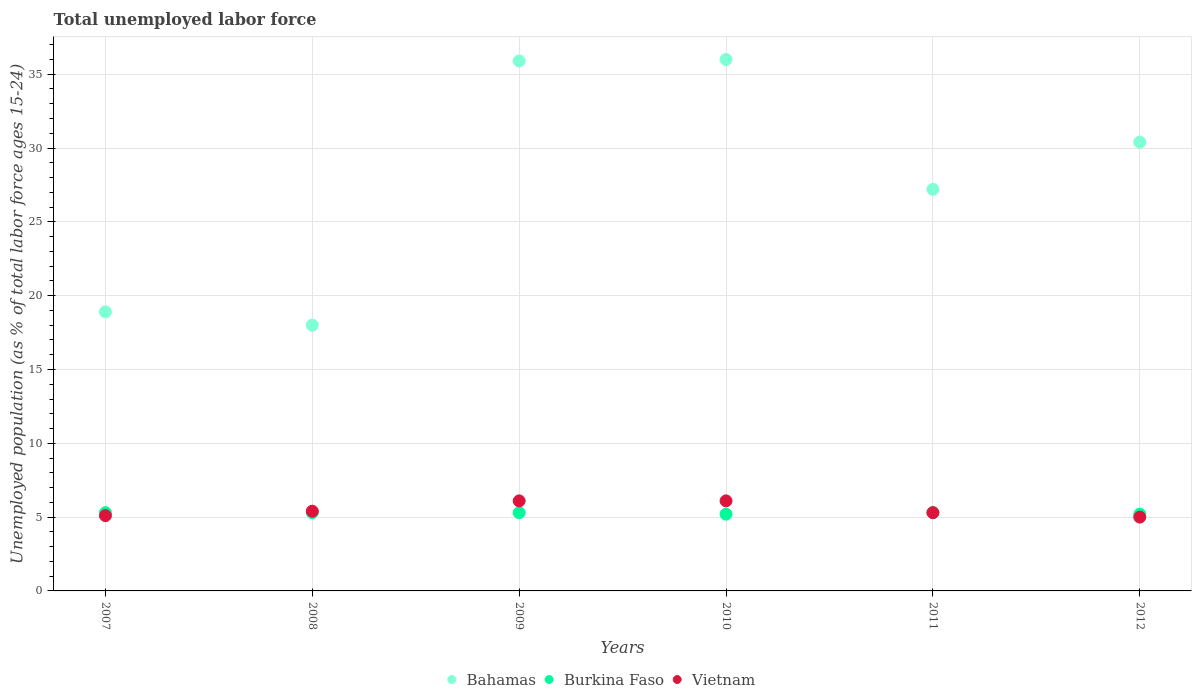Is the number of dotlines equal to the number of legend labels?
Give a very brief answer. Yes. What is the percentage of unemployed population in in Bahamas in 2007?
Offer a very short reply. 18.9. Across all years, what is the maximum percentage of unemployed population in in Vietnam?
Provide a short and direct response. 6.1. Across all years, what is the minimum percentage of unemployed population in in Bahamas?
Give a very brief answer. 18. What is the total percentage of unemployed population in in Bahamas in the graph?
Make the answer very short. 166.4. What is the difference between the percentage of unemployed population in in Bahamas in 2007 and that in 2011?
Provide a short and direct response. -8.3. What is the difference between the percentage of unemployed population in in Burkina Faso in 2008 and the percentage of unemployed population in in Bahamas in 2010?
Your answer should be compact. -30.7. What is the average percentage of unemployed population in in Bahamas per year?
Provide a succinct answer. 27.73. In the year 2012, what is the difference between the percentage of unemployed population in in Bahamas and percentage of unemployed population in in Burkina Faso?
Provide a succinct answer. 25.2. What is the ratio of the percentage of unemployed population in in Vietnam in 2009 to that in 2011?
Offer a very short reply. 1.15. Is the percentage of unemployed population in in Bahamas in 2010 less than that in 2011?
Provide a short and direct response. No. Is the difference between the percentage of unemployed population in in Bahamas in 2007 and 2012 greater than the difference between the percentage of unemployed population in in Burkina Faso in 2007 and 2012?
Your answer should be very brief. No. What is the difference between the highest and the second highest percentage of unemployed population in in Burkina Faso?
Offer a very short reply. 0. In how many years, is the percentage of unemployed population in in Bahamas greater than the average percentage of unemployed population in in Bahamas taken over all years?
Give a very brief answer. 3. Is it the case that in every year, the sum of the percentage of unemployed population in in Bahamas and percentage of unemployed population in in Burkina Faso  is greater than the percentage of unemployed population in in Vietnam?
Your answer should be compact. Yes. Does the percentage of unemployed population in in Bahamas monotonically increase over the years?
Offer a terse response. No. How many years are there in the graph?
Keep it short and to the point. 6. Are the values on the major ticks of Y-axis written in scientific E-notation?
Keep it short and to the point. No. Does the graph contain any zero values?
Offer a terse response. No. Does the graph contain grids?
Your answer should be compact. Yes. How are the legend labels stacked?
Provide a short and direct response. Horizontal. What is the title of the graph?
Your answer should be very brief. Total unemployed labor force. What is the label or title of the X-axis?
Your answer should be compact. Years. What is the label or title of the Y-axis?
Offer a very short reply. Unemployed population (as % of total labor force ages 15-24). What is the Unemployed population (as % of total labor force ages 15-24) of Bahamas in 2007?
Provide a short and direct response. 18.9. What is the Unemployed population (as % of total labor force ages 15-24) in Burkina Faso in 2007?
Your answer should be very brief. 5.3. What is the Unemployed population (as % of total labor force ages 15-24) in Vietnam in 2007?
Your answer should be very brief. 5.1. What is the Unemployed population (as % of total labor force ages 15-24) of Bahamas in 2008?
Your answer should be compact. 18. What is the Unemployed population (as % of total labor force ages 15-24) in Burkina Faso in 2008?
Provide a succinct answer. 5.3. What is the Unemployed population (as % of total labor force ages 15-24) in Vietnam in 2008?
Your response must be concise. 5.4. What is the Unemployed population (as % of total labor force ages 15-24) of Bahamas in 2009?
Make the answer very short. 35.9. What is the Unemployed population (as % of total labor force ages 15-24) of Burkina Faso in 2009?
Make the answer very short. 5.3. What is the Unemployed population (as % of total labor force ages 15-24) of Vietnam in 2009?
Make the answer very short. 6.1. What is the Unemployed population (as % of total labor force ages 15-24) in Burkina Faso in 2010?
Offer a terse response. 5.2. What is the Unemployed population (as % of total labor force ages 15-24) of Vietnam in 2010?
Offer a very short reply. 6.1. What is the Unemployed population (as % of total labor force ages 15-24) of Bahamas in 2011?
Provide a succinct answer. 27.2. What is the Unemployed population (as % of total labor force ages 15-24) in Burkina Faso in 2011?
Make the answer very short. 5.3. What is the Unemployed population (as % of total labor force ages 15-24) of Vietnam in 2011?
Make the answer very short. 5.3. What is the Unemployed population (as % of total labor force ages 15-24) in Bahamas in 2012?
Your response must be concise. 30.4. What is the Unemployed population (as % of total labor force ages 15-24) in Burkina Faso in 2012?
Provide a succinct answer. 5.2. What is the Unemployed population (as % of total labor force ages 15-24) of Vietnam in 2012?
Make the answer very short. 5. Across all years, what is the maximum Unemployed population (as % of total labor force ages 15-24) in Burkina Faso?
Ensure brevity in your answer.  5.3. Across all years, what is the maximum Unemployed population (as % of total labor force ages 15-24) of Vietnam?
Your answer should be very brief. 6.1. Across all years, what is the minimum Unemployed population (as % of total labor force ages 15-24) in Burkina Faso?
Offer a terse response. 5.2. Across all years, what is the minimum Unemployed population (as % of total labor force ages 15-24) of Vietnam?
Make the answer very short. 5. What is the total Unemployed population (as % of total labor force ages 15-24) in Bahamas in the graph?
Your response must be concise. 166.4. What is the total Unemployed population (as % of total labor force ages 15-24) in Burkina Faso in the graph?
Offer a very short reply. 31.6. What is the difference between the Unemployed population (as % of total labor force ages 15-24) in Burkina Faso in 2007 and that in 2008?
Offer a very short reply. 0. What is the difference between the Unemployed population (as % of total labor force ages 15-24) of Vietnam in 2007 and that in 2008?
Ensure brevity in your answer.  -0.3. What is the difference between the Unemployed population (as % of total labor force ages 15-24) in Bahamas in 2007 and that in 2010?
Offer a very short reply. -17.1. What is the difference between the Unemployed population (as % of total labor force ages 15-24) in Burkina Faso in 2007 and that in 2010?
Your answer should be compact. 0.1. What is the difference between the Unemployed population (as % of total labor force ages 15-24) in Vietnam in 2007 and that in 2010?
Keep it short and to the point. -1. What is the difference between the Unemployed population (as % of total labor force ages 15-24) in Vietnam in 2007 and that in 2011?
Give a very brief answer. -0.2. What is the difference between the Unemployed population (as % of total labor force ages 15-24) in Bahamas in 2007 and that in 2012?
Make the answer very short. -11.5. What is the difference between the Unemployed population (as % of total labor force ages 15-24) in Burkina Faso in 2007 and that in 2012?
Your response must be concise. 0.1. What is the difference between the Unemployed population (as % of total labor force ages 15-24) in Vietnam in 2007 and that in 2012?
Offer a very short reply. 0.1. What is the difference between the Unemployed population (as % of total labor force ages 15-24) of Bahamas in 2008 and that in 2009?
Give a very brief answer. -17.9. What is the difference between the Unemployed population (as % of total labor force ages 15-24) in Burkina Faso in 2008 and that in 2009?
Offer a terse response. 0. What is the difference between the Unemployed population (as % of total labor force ages 15-24) of Burkina Faso in 2008 and that in 2011?
Your response must be concise. 0. What is the difference between the Unemployed population (as % of total labor force ages 15-24) in Burkina Faso in 2008 and that in 2012?
Provide a short and direct response. 0.1. What is the difference between the Unemployed population (as % of total labor force ages 15-24) in Bahamas in 2009 and that in 2010?
Your response must be concise. -0.1. What is the difference between the Unemployed population (as % of total labor force ages 15-24) in Burkina Faso in 2009 and that in 2010?
Offer a terse response. 0.1. What is the difference between the Unemployed population (as % of total labor force ages 15-24) of Vietnam in 2009 and that in 2010?
Your response must be concise. 0. What is the difference between the Unemployed population (as % of total labor force ages 15-24) in Vietnam in 2009 and that in 2011?
Your response must be concise. 0.8. What is the difference between the Unemployed population (as % of total labor force ages 15-24) in Vietnam in 2009 and that in 2012?
Provide a succinct answer. 1.1. What is the difference between the Unemployed population (as % of total labor force ages 15-24) in Bahamas in 2010 and that in 2011?
Ensure brevity in your answer.  8.8. What is the difference between the Unemployed population (as % of total labor force ages 15-24) of Burkina Faso in 2010 and that in 2012?
Make the answer very short. 0. What is the difference between the Unemployed population (as % of total labor force ages 15-24) in Vietnam in 2010 and that in 2012?
Your answer should be very brief. 1.1. What is the difference between the Unemployed population (as % of total labor force ages 15-24) in Bahamas in 2011 and that in 2012?
Keep it short and to the point. -3.2. What is the difference between the Unemployed population (as % of total labor force ages 15-24) in Bahamas in 2007 and the Unemployed population (as % of total labor force ages 15-24) in Burkina Faso in 2008?
Make the answer very short. 13.6. What is the difference between the Unemployed population (as % of total labor force ages 15-24) of Bahamas in 2007 and the Unemployed population (as % of total labor force ages 15-24) of Burkina Faso in 2009?
Provide a succinct answer. 13.6. What is the difference between the Unemployed population (as % of total labor force ages 15-24) in Bahamas in 2007 and the Unemployed population (as % of total labor force ages 15-24) in Vietnam in 2009?
Ensure brevity in your answer.  12.8. What is the difference between the Unemployed population (as % of total labor force ages 15-24) of Bahamas in 2007 and the Unemployed population (as % of total labor force ages 15-24) of Burkina Faso in 2010?
Your answer should be very brief. 13.7. What is the difference between the Unemployed population (as % of total labor force ages 15-24) of Burkina Faso in 2007 and the Unemployed population (as % of total labor force ages 15-24) of Vietnam in 2010?
Offer a terse response. -0.8. What is the difference between the Unemployed population (as % of total labor force ages 15-24) in Bahamas in 2007 and the Unemployed population (as % of total labor force ages 15-24) in Burkina Faso in 2011?
Ensure brevity in your answer.  13.6. What is the difference between the Unemployed population (as % of total labor force ages 15-24) in Burkina Faso in 2007 and the Unemployed population (as % of total labor force ages 15-24) in Vietnam in 2011?
Your answer should be compact. 0. What is the difference between the Unemployed population (as % of total labor force ages 15-24) of Bahamas in 2007 and the Unemployed population (as % of total labor force ages 15-24) of Vietnam in 2012?
Give a very brief answer. 13.9. What is the difference between the Unemployed population (as % of total labor force ages 15-24) of Bahamas in 2008 and the Unemployed population (as % of total labor force ages 15-24) of Vietnam in 2009?
Make the answer very short. 11.9. What is the difference between the Unemployed population (as % of total labor force ages 15-24) in Burkina Faso in 2008 and the Unemployed population (as % of total labor force ages 15-24) in Vietnam in 2009?
Your answer should be very brief. -0.8. What is the difference between the Unemployed population (as % of total labor force ages 15-24) of Bahamas in 2008 and the Unemployed population (as % of total labor force ages 15-24) of Burkina Faso in 2010?
Your answer should be very brief. 12.8. What is the difference between the Unemployed population (as % of total labor force ages 15-24) of Bahamas in 2008 and the Unemployed population (as % of total labor force ages 15-24) of Vietnam in 2010?
Your response must be concise. 11.9. What is the difference between the Unemployed population (as % of total labor force ages 15-24) in Burkina Faso in 2008 and the Unemployed population (as % of total labor force ages 15-24) in Vietnam in 2010?
Provide a succinct answer. -0.8. What is the difference between the Unemployed population (as % of total labor force ages 15-24) in Bahamas in 2008 and the Unemployed population (as % of total labor force ages 15-24) in Vietnam in 2011?
Provide a short and direct response. 12.7. What is the difference between the Unemployed population (as % of total labor force ages 15-24) in Burkina Faso in 2008 and the Unemployed population (as % of total labor force ages 15-24) in Vietnam in 2012?
Offer a terse response. 0.3. What is the difference between the Unemployed population (as % of total labor force ages 15-24) in Bahamas in 2009 and the Unemployed population (as % of total labor force ages 15-24) in Burkina Faso in 2010?
Your answer should be very brief. 30.7. What is the difference between the Unemployed population (as % of total labor force ages 15-24) of Bahamas in 2009 and the Unemployed population (as % of total labor force ages 15-24) of Vietnam in 2010?
Your answer should be very brief. 29.8. What is the difference between the Unemployed population (as % of total labor force ages 15-24) in Burkina Faso in 2009 and the Unemployed population (as % of total labor force ages 15-24) in Vietnam in 2010?
Offer a terse response. -0.8. What is the difference between the Unemployed population (as % of total labor force ages 15-24) of Bahamas in 2009 and the Unemployed population (as % of total labor force ages 15-24) of Burkina Faso in 2011?
Keep it short and to the point. 30.6. What is the difference between the Unemployed population (as % of total labor force ages 15-24) of Bahamas in 2009 and the Unemployed population (as % of total labor force ages 15-24) of Vietnam in 2011?
Provide a succinct answer. 30.6. What is the difference between the Unemployed population (as % of total labor force ages 15-24) in Bahamas in 2009 and the Unemployed population (as % of total labor force ages 15-24) in Burkina Faso in 2012?
Your answer should be very brief. 30.7. What is the difference between the Unemployed population (as % of total labor force ages 15-24) of Bahamas in 2009 and the Unemployed population (as % of total labor force ages 15-24) of Vietnam in 2012?
Give a very brief answer. 30.9. What is the difference between the Unemployed population (as % of total labor force ages 15-24) of Burkina Faso in 2009 and the Unemployed population (as % of total labor force ages 15-24) of Vietnam in 2012?
Your response must be concise. 0.3. What is the difference between the Unemployed population (as % of total labor force ages 15-24) in Bahamas in 2010 and the Unemployed population (as % of total labor force ages 15-24) in Burkina Faso in 2011?
Your answer should be compact. 30.7. What is the difference between the Unemployed population (as % of total labor force ages 15-24) in Bahamas in 2010 and the Unemployed population (as % of total labor force ages 15-24) in Vietnam in 2011?
Your answer should be very brief. 30.7. What is the difference between the Unemployed population (as % of total labor force ages 15-24) in Bahamas in 2010 and the Unemployed population (as % of total labor force ages 15-24) in Burkina Faso in 2012?
Give a very brief answer. 30.8. What is the average Unemployed population (as % of total labor force ages 15-24) of Bahamas per year?
Provide a short and direct response. 27.73. What is the average Unemployed population (as % of total labor force ages 15-24) in Burkina Faso per year?
Keep it short and to the point. 5.27. In the year 2007, what is the difference between the Unemployed population (as % of total labor force ages 15-24) in Bahamas and Unemployed population (as % of total labor force ages 15-24) in Burkina Faso?
Make the answer very short. 13.6. In the year 2008, what is the difference between the Unemployed population (as % of total labor force ages 15-24) in Bahamas and Unemployed population (as % of total labor force ages 15-24) in Burkina Faso?
Offer a very short reply. 12.7. In the year 2009, what is the difference between the Unemployed population (as % of total labor force ages 15-24) of Bahamas and Unemployed population (as % of total labor force ages 15-24) of Burkina Faso?
Offer a very short reply. 30.6. In the year 2009, what is the difference between the Unemployed population (as % of total labor force ages 15-24) in Bahamas and Unemployed population (as % of total labor force ages 15-24) in Vietnam?
Your answer should be compact. 29.8. In the year 2010, what is the difference between the Unemployed population (as % of total labor force ages 15-24) in Bahamas and Unemployed population (as % of total labor force ages 15-24) in Burkina Faso?
Provide a short and direct response. 30.8. In the year 2010, what is the difference between the Unemployed population (as % of total labor force ages 15-24) of Bahamas and Unemployed population (as % of total labor force ages 15-24) of Vietnam?
Keep it short and to the point. 29.9. In the year 2011, what is the difference between the Unemployed population (as % of total labor force ages 15-24) in Bahamas and Unemployed population (as % of total labor force ages 15-24) in Burkina Faso?
Ensure brevity in your answer.  21.9. In the year 2011, what is the difference between the Unemployed population (as % of total labor force ages 15-24) of Bahamas and Unemployed population (as % of total labor force ages 15-24) of Vietnam?
Ensure brevity in your answer.  21.9. In the year 2011, what is the difference between the Unemployed population (as % of total labor force ages 15-24) of Burkina Faso and Unemployed population (as % of total labor force ages 15-24) of Vietnam?
Your answer should be very brief. 0. In the year 2012, what is the difference between the Unemployed population (as % of total labor force ages 15-24) in Bahamas and Unemployed population (as % of total labor force ages 15-24) in Burkina Faso?
Keep it short and to the point. 25.2. In the year 2012, what is the difference between the Unemployed population (as % of total labor force ages 15-24) in Bahamas and Unemployed population (as % of total labor force ages 15-24) in Vietnam?
Ensure brevity in your answer.  25.4. What is the ratio of the Unemployed population (as % of total labor force ages 15-24) of Bahamas in 2007 to that in 2008?
Offer a terse response. 1.05. What is the ratio of the Unemployed population (as % of total labor force ages 15-24) of Burkina Faso in 2007 to that in 2008?
Your answer should be compact. 1. What is the ratio of the Unemployed population (as % of total labor force ages 15-24) of Vietnam in 2007 to that in 2008?
Give a very brief answer. 0.94. What is the ratio of the Unemployed population (as % of total labor force ages 15-24) in Bahamas in 2007 to that in 2009?
Provide a short and direct response. 0.53. What is the ratio of the Unemployed population (as % of total labor force ages 15-24) of Vietnam in 2007 to that in 2009?
Offer a terse response. 0.84. What is the ratio of the Unemployed population (as % of total labor force ages 15-24) of Bahamas in 2007 to that in 2010?
Give a very brief answer. 0.53. What is the ratio of the Unemployed population (as % of total labor force ages 15-24) in Burkina Faso in 2007 to that in 2010?
Offer a very short reply. 1.02. What is the ratio of the Unemployed population (as % of total labor force ages 15-24) of Vietnam in 2007 to that in 2010?
Offer a very short reply. 0.84. What is the ratio of the Unemployed population (as % of total labor force ages 15-24) in Bahamas in 2007 to that in 2011?
Keep it short and to the point. 0.69. What is the ratio of the Unemployed population (as % of total labor force ages 15-24) of Burkina Faso in 2007 to that in 2011?
Provide a succinct answer. 1. What is the ratio of the Unemployed population (as % of total labor force ages 15-24) in Vietnam in 2007 to that in 2011?
Ensure brevity in your answer.  0.96. What is the ratio of the Unemployed population (as % of total labor force ages 15-24) in Bahamas in 2007 to that in 2012?
Make the answer very short. 0.62. What is the ratio of the Unemployed population (as % of total labor force ages 15-24) in Burkina Faso in 2007 to that in 2012?
Keep it short and to the point. 1.02. What is the ratio of the Unemployed population (as % of total labor force ages 15-24) in Bahamas in 2008 to that in 2009?
Ensure brevity in your answer.  0.5. What is the ratio of the Unemployed population (as % of total labor force ages 15-24) of Burkina Faso in 2008 to that in 2009?
Ensure brevity in your answer.  1. What is the ratio of the Unemployed population (as % of total labor force ages 15-24) of Vietnam in 2008 to that in 2009?
Ensure brevity in your answer.  0.89. What is the ratio of the Unemployed population (as % of total labor force ages 15-24) of Bahamas in 2008 to that in 2010?
Your answer should be compact. 0.5. What is the ratio of the Unemployed population (as % of total labor force ages 15-24) of Burkina Faso in 2008 to that in 2010?
Your answer should be compact. 1.02. What is the ratio of the Unemployed population (as % of total labor force ages 15-24) of Vietnam in 2008 to that in 2010?
Offer a very short reply. 0.89. What is the ratio of the Unemployed population (as % of total labor force ages 15-24) of Bahamas in 2008 to that in 2011?
Provide a short and direct response. 0.66. What is the ratio of the Unemployed population (as % of total labor force ages 15-24) of Burkina Faso in 2008 to that in 2011?
Your response must be concise. 1. What is the ratio of the Unemployed population (as % of total labor force ages 15-24) of Vietnam in 2008 to that in 2011?
Your response must be concise. 1.02. What is the ratio of the Unemployed population (as % of total labor force ages 15-24) in Bahamas in 2008 to that in 2012?
Provide a succinct answer. 0.59. What is the ratio of the Unemployed population (as % of total labor force ages 15-24) in Burkina Faso in 2008 to that in 2012?
Make the answer very short. 1.02. What is the ratio of the Unemployed population (as % of total labor force ages 15-24) in Vietnam in 2008 to that in 2012?
Offer a terse response. 1.08. What is the ratio of the Unemployed population (as % of total labor force ages 15-24) in Bahamas in 2009 to that in 2010?
Offer a terse response. 1. What is the ratio of the Unemployed population (as % of total labor force ages 15-24) of Burkina Faso in 2009 to that in 2010?
Give a very brief answer. 1.02. What is the ratio of the Unemployed population (as % of total labor force ages 15-24) in Vietnam in 2009 to that in 2010?
Offer a very short reply. 1. What is the ratio of the Unemployed population (as % of total labor force ages 15-24) of Bahamas in 2009 to that in 2011?
Make the answer very short. 1.32. What is the ratio of the Unemployed population (as % of total labor force ages 15-24) of Vietnam in 2009 to that in 2011?
Offer a very short reply. 1.15. What is the ratio of the Unemployed population (as % of total labor force ages 15-24) of Bahamas in 2009 to that in 2012?
Provide a short and direct response. 1.18. What is the ratio of the Unemployed population (as % of total labor force ages 15-24) in Burkina Faso in 2009 to that in 2012?
Your answer should be compact. 1.02. What is the ratio of the Unemployed population (as % of total labor force ages 15-24) in Vietnam in 2009 to that in 2012?
Provide a succinct answer. 1.22. What is the ratio of the Unemployed population (as % of total labor force ages 15-24) in Bahamas in 2010 to that in 2011?
Your response must be concise. 1.32. What is the ratio of the Unemployed population (as % of total labor force ages 15-24) of Burkina Faso in 2010 to that in 2011?
Give a very brief answer. 0.98. What is the ratio of the Unemployed population (as % of total labor force ages 15-24) of Vietnam in 2010 to that in 2011?
Give a very brief answer. 1.15. What is the ratio of the Unemployed population (as % of total labor force ages 15-24) of Bahamas in 2010 to that in 2012?
Make the answer very short. 1.18. What is the ratio of the Unemployed population (as % of total labor force ages 15-24) of Vietnam in 2010 to that in 2012?
Your answer should be compact. 1.22. What is the ratio of the Unemployed population (as % of total labor force ages 15-24) of Bahamas in 2011 to that in 2012?
Give a very brief answer. 0.89. What is the ratio of the Unemployed population (as % of total labor force ages 15-24) in Burkina Faso in 2011 to that in 2012?
Offer a very short reply. 1.02. What is the ratio of the Unemployed population (as % of total labor force ages 15-24) in Vietnam in 2011 to that in 2012?
Your response must be concise. 1.06. What is the difference between the highest and the second highest Unemployed population (as % of total labor force ages 15-24) of Bahamas?
Keep it short and to the point. 0.1. What is the difference between the highest and the second highest Unemployed population (as % of total labor force ages 15-24) of Burkina Faso?
Offer a terse response. 0. What is the difference between the highest and the second highest Unemployed population (as % of total labor force ages 15-24) in Vietnam?
Keep it short and to the point. 0. What is the difference between the highest and the lowest Unemployed population (as % of total labor force ages 15-24) of Bahamas?
Your answer should be very brief. 18. 